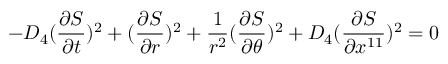<formula> <loc_0><loc_0><loc_500><loc_500>- D _ { 4 } ( { \frac { \partial S } { \partial t } } ) ^ { 2 } + ( { \frac { \partial S } { \partial r } } ) ^ { 2 } + { \frac { 1 } { r ^ { 2 } } } ( { \frac { \partial S } { \partial \theta } } ) ^ { 2 } + D _ { 4 } ( { \frac { \partial S } { \partial x ^ { 1 1 } } } ) ^ { 2 } = 0</formula> 